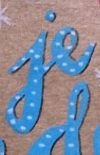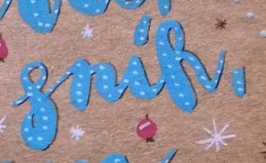What text is displayed in these images sequentially, separated by a semicolon? je; snik, 